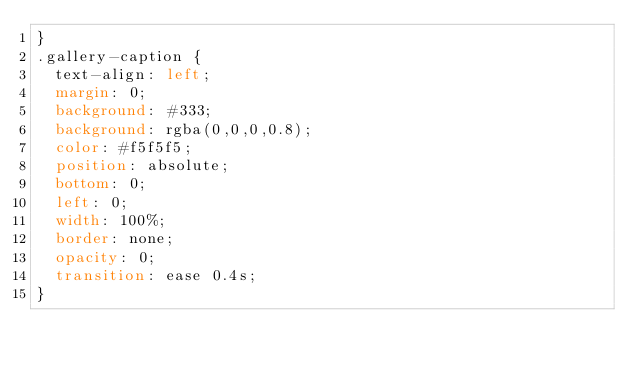Convert code to text. <code><loc_0><loc_0><loc_500><loc_500><_CSS_>}
.gallery-caption {
	text-align: left;
	margin: 0;
	background: #333;
	background: rgba(0,0,0,0.8);
	color: #f5f5f5;
	position: absolute;
	bottom: 0;
	left: 0;
	width: 100%;
	border: none;
	opacity: 0;
	transition: ease 0.4s;
}</code> 